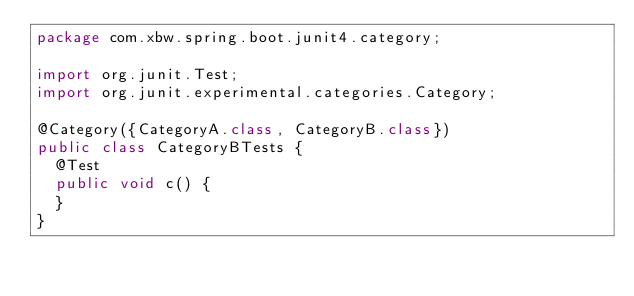Convert code to text. <code><loc_0><loc_0><loc_500><loc_500><_Java_>package com.xbw.spring.boot.junit4.category;

import org.junit.Test;
import org.junit.experimental.categories.Category;

@Category({CategoryA.class, CategoryB.class})
public class CategoryBTests {
  @Test
  public void c() {
  }
}</code> 